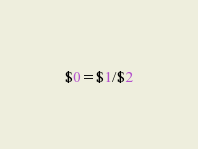<code> <loc_0><loc_0><loc_500><loc_500><_Awk_>$0=$1/$2</code> 